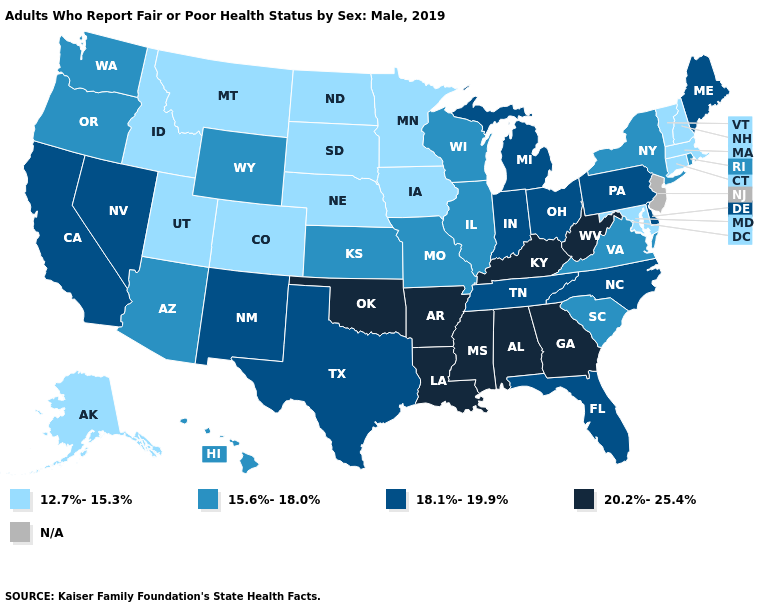Among the states that border Oregon , does California have the lowest value?
Answer briefly. No. What is the value of Florida?
Concise answer only. 18.1%-19.9%. Which states hav the highest value in the West?
Short answer required. California, Nevada, New Mexico. What is the value of Missouri?
Write a very short answer. 15.6%-18.0%. What is the value of Kansas?
Write a very short answer. 15.6%-18.0%. What is the value of Mississippi?
Give a very brief answer. 20.2%-25.4%. Name the states that have a value in the range N/A?
Write a very short answer. New Jersey. What is the value of South Dakota?
Answer briefly. 12.7%-15.3%. Does Georgia have the highest value in the USA?
Concise answer only. Yes. Name the states that have a value in the range 12.7%-15.3%?
Give a very brief answer. Alaska, Colorado, Connecticut, Idaho, Iowa, Maryland, Massachusetts, Minnesota, Montana, Nebraska, New Hampshire, North Dakota, South Dakota, Utah, Vermont. Among the states that border Alabama , does Florida have the lowest value?
Concise answer only. Yes. Among the states that border Georgia , which have the lowest value?
Answer briefly. South Carolina. What is the value of North Carolina?
Give a very brief answer. 18.1%-19.9%. What is the lowest value in the USA?
Give a very brief answer. 12.7%-15.3%. What is the value of Texas?
Short answer required. 18.1%-19.9%. 